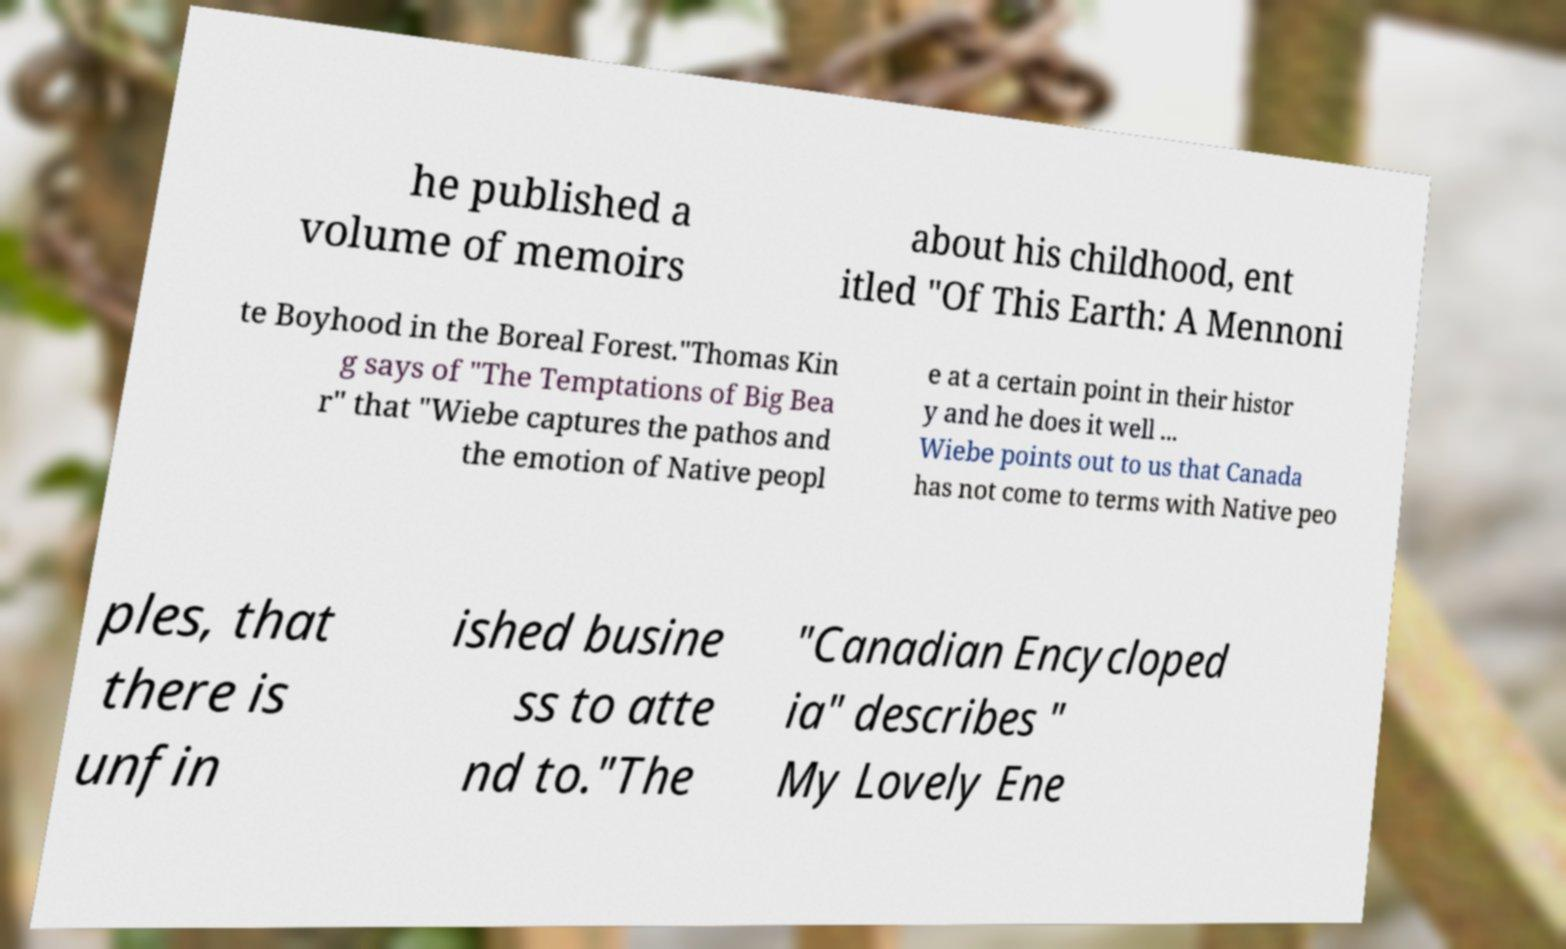Could you assist in decoding the text presented in this image and type it out clearly? he published a volume of memoirs about his childhood, ent itled "Of This Earth: A Mennoni te Boyhood in the Boreal Forest."Thomas Kin g says of "The Temptations of Big Bea r" that "Wiebe captures the pathos and the emotion of Native peopl e at a certain point in their histor y and he does it well ... Wiebe points out to us that Canada has not come to terms with Native peo ples, that there is unfin ished busine ss to atte nd to."The "Canadian Encycloped ia" describes " My Lovely Ene 